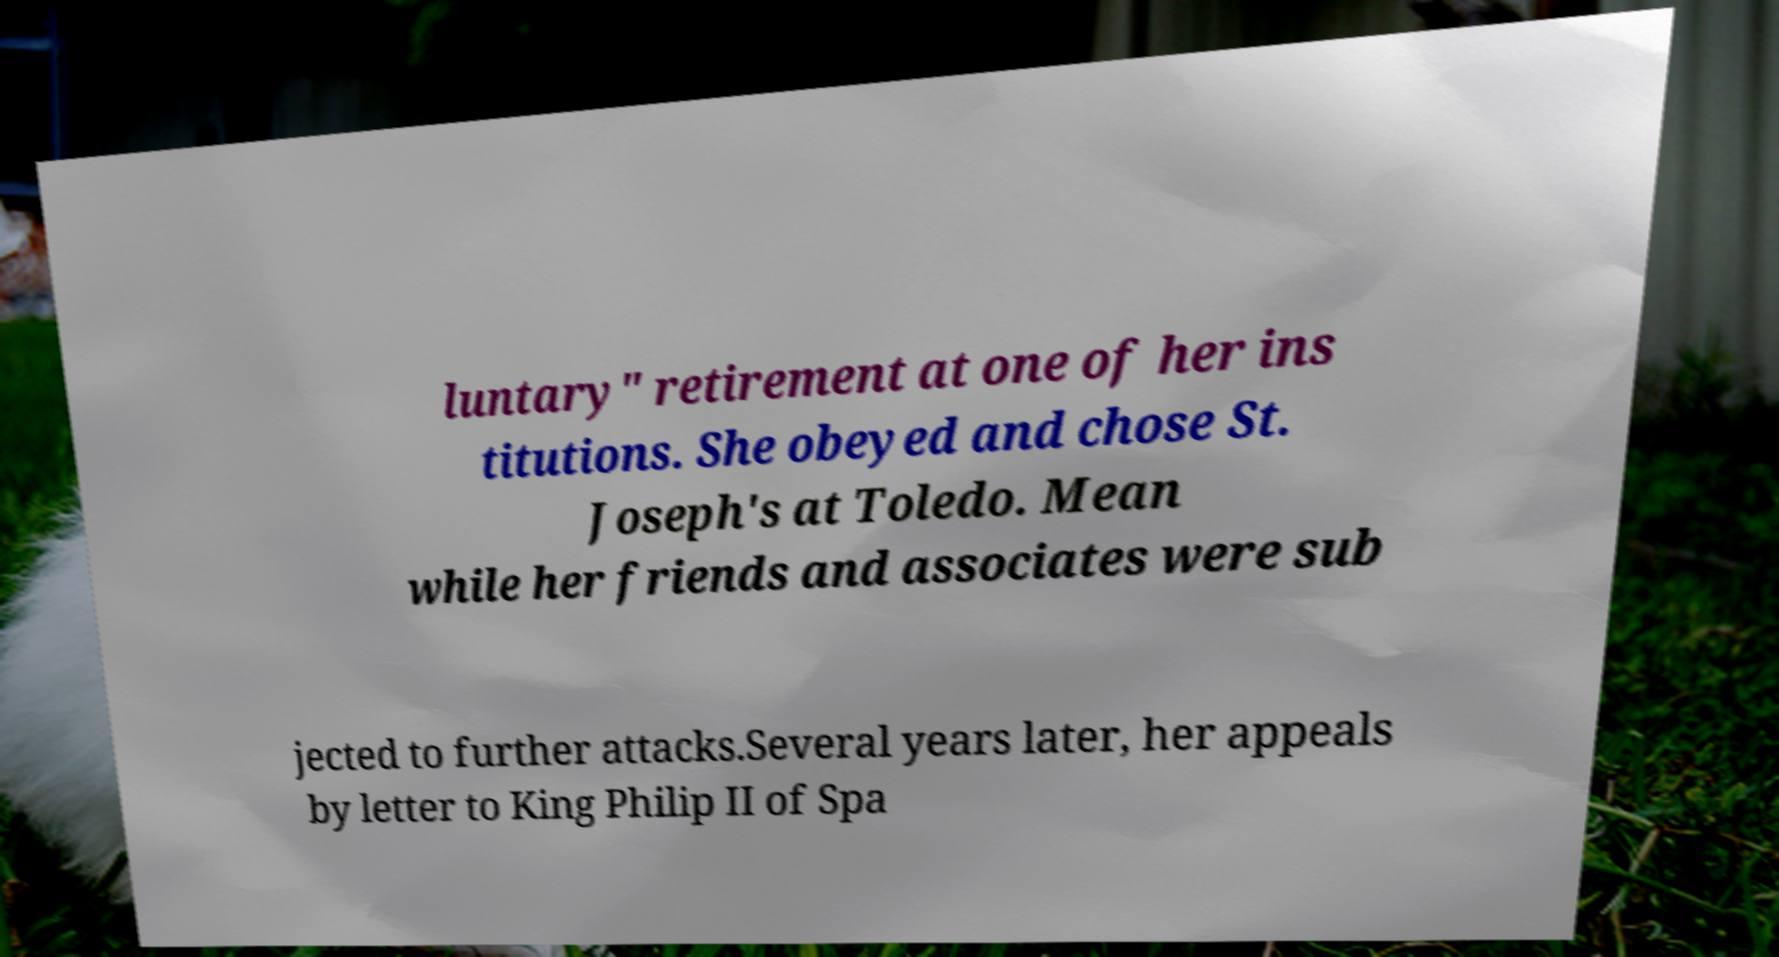Please identify and transcribe the text found in this image. luntary" retirement at one of her ins titutions. She obeyed and chose St. Joseph's at Toledo. Mean while her friends and associates were sub jected to further attacks.Several years later, her appeals by letter to King Philip II of Spa 